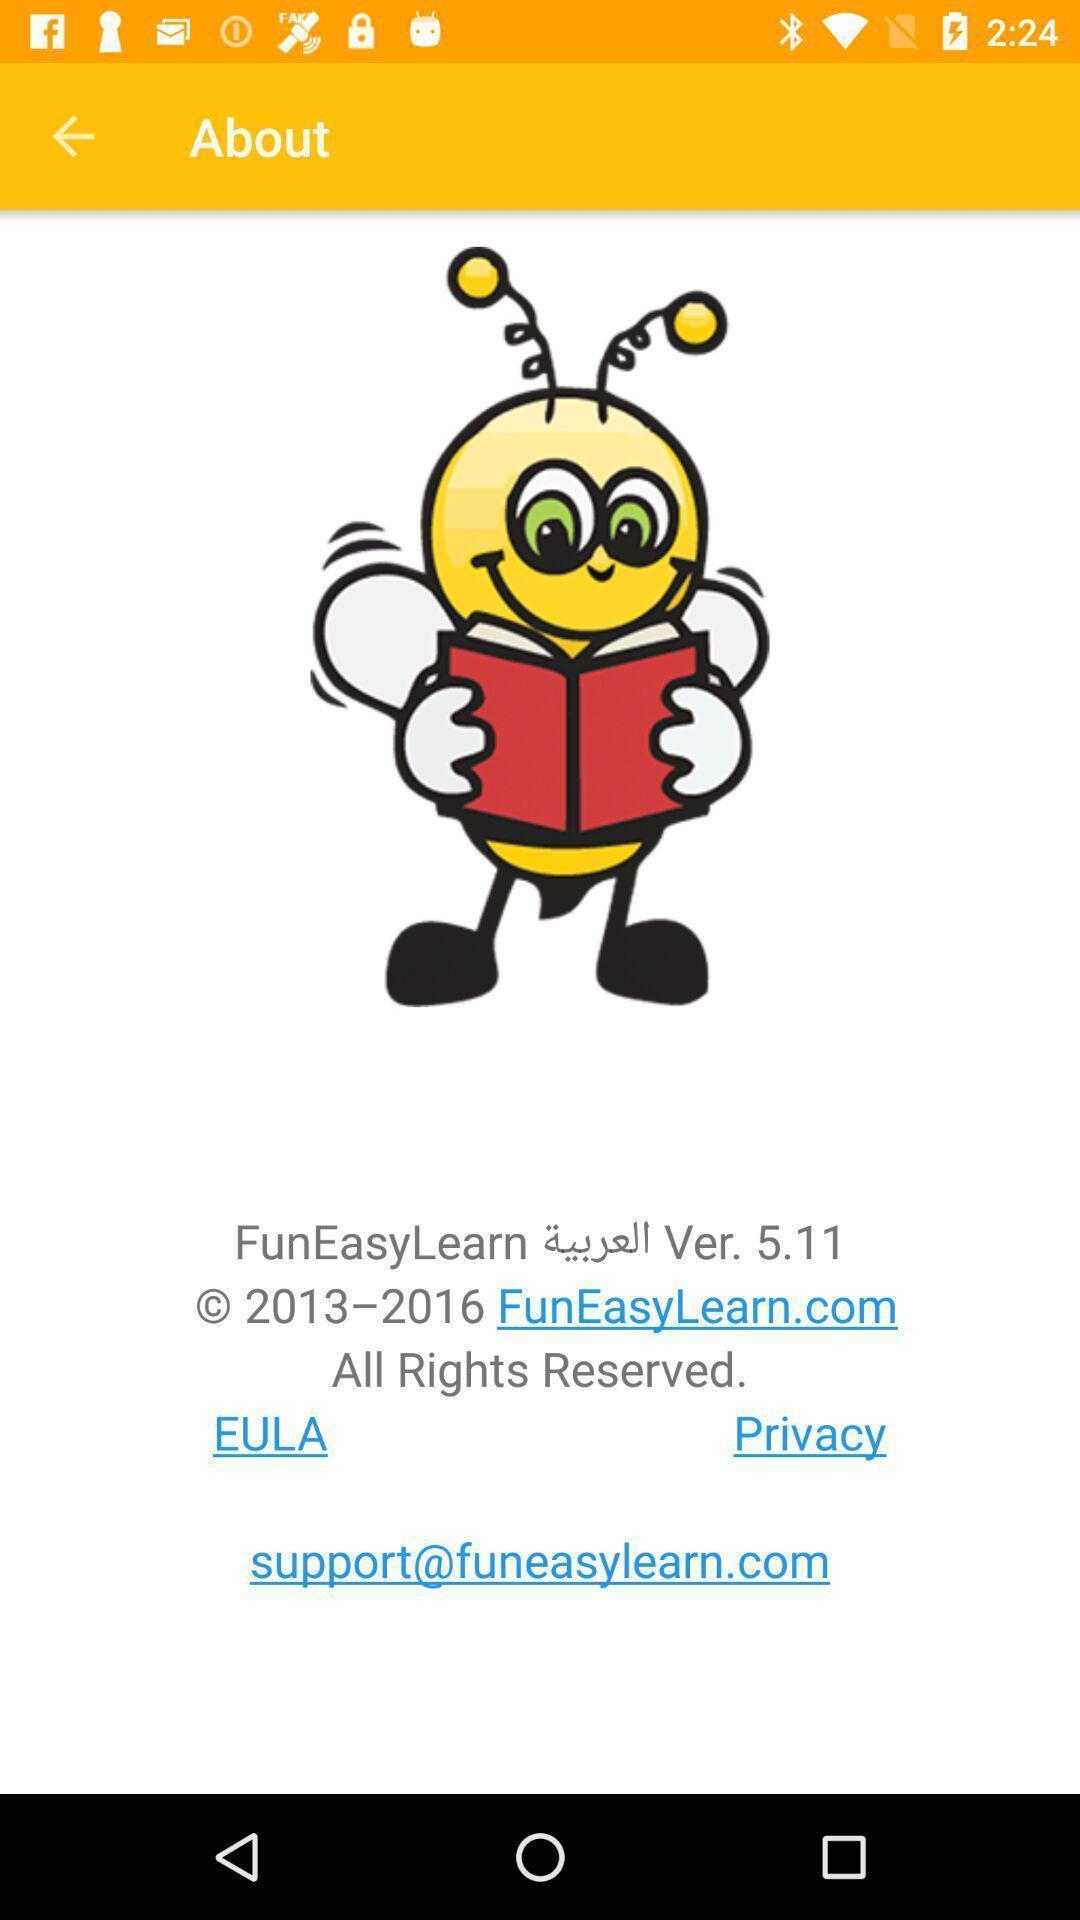Summarize the main components in this picture. Screen showing about. 